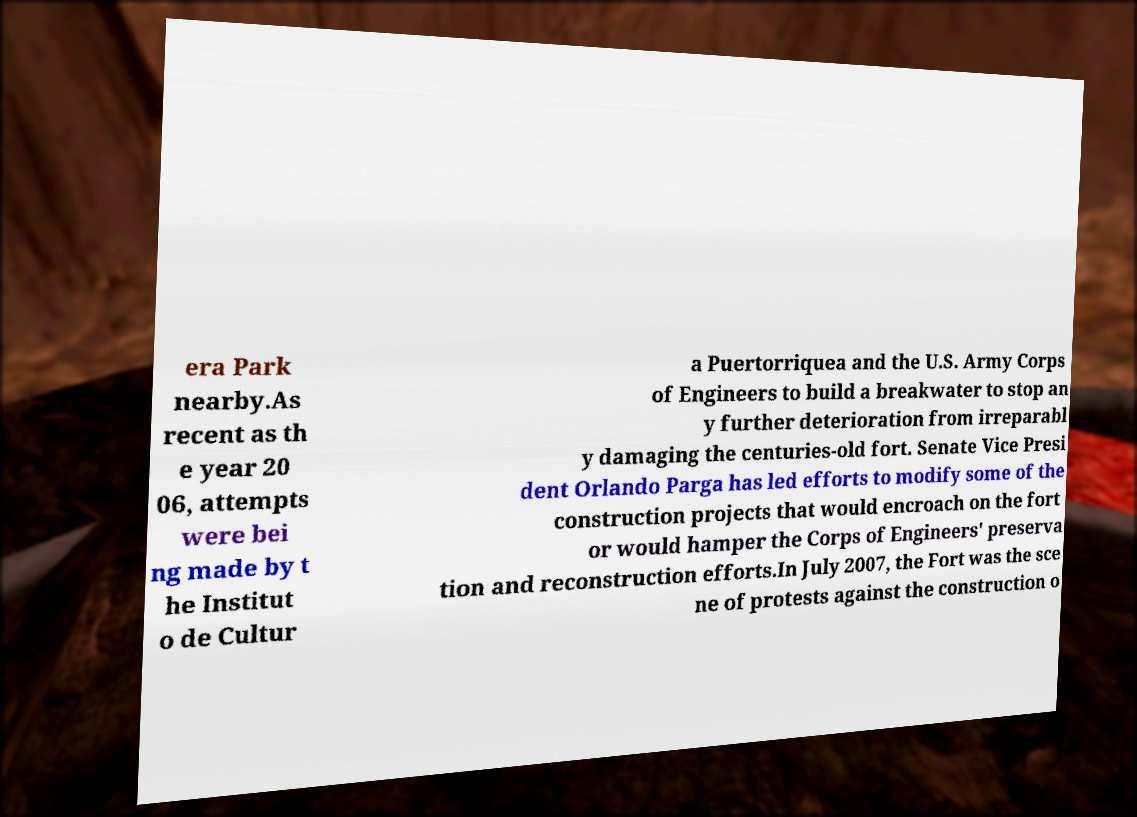Can you read and provide the text displayed in the image?This photo seems to have some interesting text. Can you extract and type it out for me? era Park nearby.As recent as th e year 20 06, attempts were bei ng made by t he Institut o de Cultur a Puertorriquea and the U.S. Army Corps of Engineers to build a breakwater to stop an y further deterioration from irreparabl y damaging the centuries-old fort. Senate Vice Presi dent Orlando Parga has led efforts to modify some of the construction projects that would encroach on the fort or would hamper the Corps of Engineers' preserva tion and reconstruction efforts.In July 2007, the Fort was the sce ne of protests against the construction o 